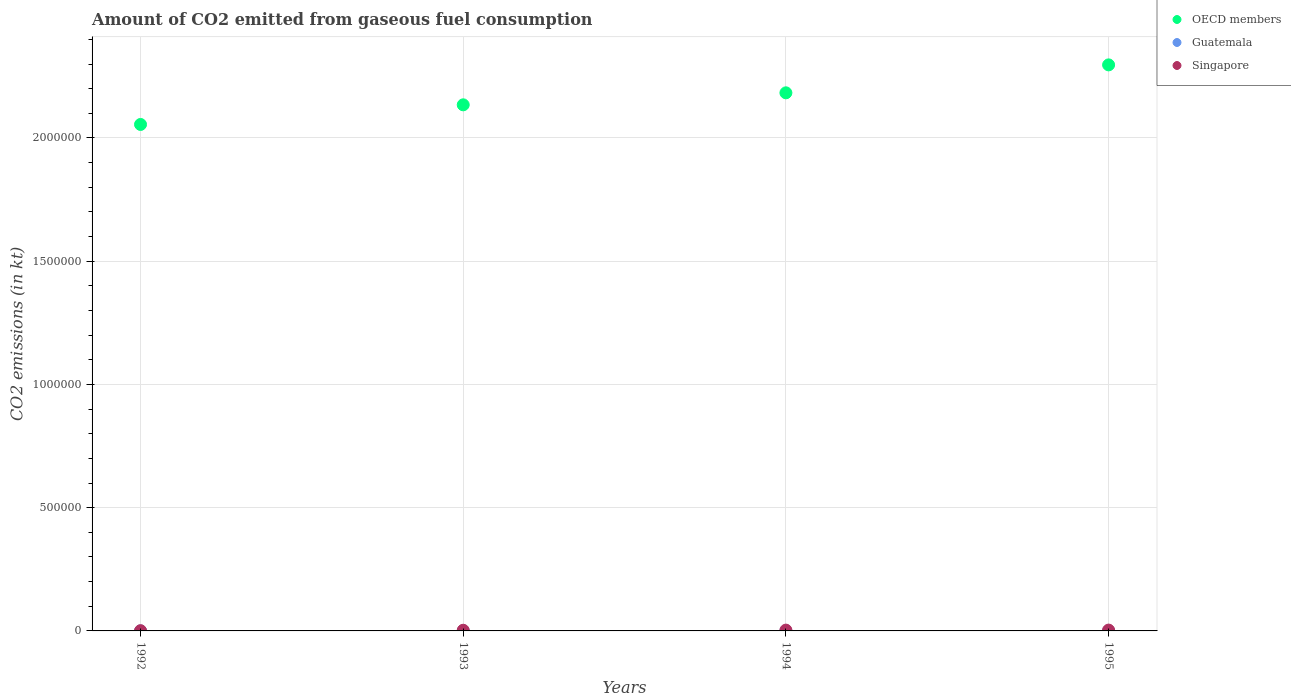How many different coloured dotlines are there?
Provide a succinct answer. 3. What is the amount of CO2 emitted in Guatemala in 1994?
Your answer should be very brief. 18.34. Across all years, what is the maximum amount of CO2 emitted in OECD members?
Give a very brief answer. 2.30e+06. Across all years, what is the minimum amount of CO2 emitted in Singapore?
Ensure brevity in your answer.  916.75. What is the total amount of CO2 emitted in OECD members in the graph?
Provide a succinct answer. 8.67e+06. What is the difference between the amount of CO2 emitted in OECD members in 1992 and that in 1994?
Provide a short and direct response. -1.28e+05. What is the difference between the amount of CO2 emitted in Guatemala in 1993 and the amount of CO2 emitted in OECD members in 1994?
Provide a succinct answer. -2.18e+06. What is the average amount of CO2 emitted in Singapore per year?
Ensure brevity in your answer.  2570.57. In the year 1994, what is the difference between the amount of CO2 emitted in Singapore and amount of CO2 emitted in OECD members?
Give a very brief answer. -2.18e+06. What is the ratio of the amount of CO2 emitted in Guatemala in 1994 to that in 1995?
Offer a terse response. 0.83. What is the difference between the highest and the second highest amount of CO2 emitted in Guatemala?
Your answer should be compact. 3.67. What is the difference between the highest and the lowest amount of CO2 emitted in Guatemala?
Offer a very short reply. 3.67. Is the sum of the amount of CO2 emitted in OECD members in 1992 and 1993 greater than the maximum amount of CO2 emitted in Guatemala across all years?
Keep it short and to the point. Yes. Is the amount of CO2 emitted in OECD members strictly greater than the amount of CO2 emitted in Singapore over the years?
Your response must be concise. Yes. How many dotlines are there?
Provide a short and direct response. 3. How many years are there in the graph?
Your answer should be compact. 4. Are the values on the major ticks of Y-axis written in scientific E-notation?
Provide a succinct answer. No. Does the graph contain grids?
Provide a short and direct response. Yes. How many legend labels are there?
Make the answer very short. 3. What is the title of the graph?
Ensure brevity in your answer.  Amount of CO2 emitted from gaseous fuel consumption. Does "Cayman Islands" appear as one of the legend labels in the graph?
Your answer should be compact. No. What is the label or title of the X-axis?
Make the answer very short. Years. What is the label or title of the Y-axis?
Offer a terse response. CO2 emissions (in kt). What is the CO2 emissions (in kt) in OECD members in 1992?
Ensure brevity in your answer.  2.05e+06. What is the CO2 emissions (in kt) of Guatemala in 1992?
Offer a terse response. 18.34. What is the CO2 emissions (in kt) of Singapore in 1992?
Offer a very short reply. 916.75. What is the CO2 emissions (in kt) in OECD members in 1993?
Keep it short and to the point. 2.13e+06. What is the CO2 emissions (in kt) in Guatemala in 1993?
Your answer should be compact. 18.34. What is the CO2 emissions (in kt) in Singapore in 1993?
Provide a short and direct response. 2728.25. What is the CO2 emissions (in kt) of OECD members in 1994?
Keep it short and to the point. 2.18e+06. What is the CO2 emissions (in kt) in Guatemala in 1994?
Your response must be concise. 18.34. What is the CO2 emissions (in kt) of Singapore in 1994?
Ensure brevity in your answer.  3252.63. What is the CO2 emissions (in kt) in OECD members in 1995?
Your response must be concise. 2.30e+06. What is the CO2 emissions (in kt) in Guatemala in 1995?
Offer a terse response. 22. What is the CO2 emissions (in kt) in Singapore in 1995?
Make the answer very short. 3384.64. Across all years, what is the maximum CO2 emissions (in kt) of OECD members?
Your answer should be very brief. 2.30e+06. Across all years, what is the maximum CO2 emissions (in kt) in Guatemala?
Offer a terse response. 22. Across all years, what is the maximum CO2 emissions (in kt) in Singapore?
Your answer should be very brief. 3384.64. Across all years, what is the minimum CO2 emissions (in kt) of OECD members?
Provide a short and direct response. 2.05e+06. Across all years, what is the minimum CO2 emissions (in kt) of Guatemala?
Provide a short and direct response. 18.34. Across all years, what is the minimum CO2 emissions (in kt) in Singapore?
Your answer should be very brief. 916.75. What is the total CO2 emissions (in kt) of OECD members in the graph?
Make the answer very short. 8.67e+06. What is the total CO2 emissions (in kt) in Guatemala in the graph?
Make the answer very short. 77.01. What is the total CO2 emissions (in kt) of Singapore in the graph?
Your answer should be very brief. 1.03e+04. What is the difference between the CO2 emissions (in kt) in OECD members in 1992 and that in 1993?
Your answer should be compact. -7.97e+04. What is the difference between the CO2 emissions (in kt) in Singapore in 1992 and that in 1993?
Offer a terse response. -1811.5. What is the difference between the CO2 emissions (in kt) in OECD members in 1992 and that in 1994?
Offer a terse response. -1.28e+05. What is the difference between the CO2 emissions (in kt) of Singapore in 1992 and that in 1994?
Keep it short and to the point. -2335.88. What is the difference between the CO2 emissions (in kt) in OECD members in 1992 and that in 1995?
Make the answer very short. -2.42e+05. What is the difference between the CO2 emissions (in kt) of Guatemala in 1992 and that in 1995?
Your response must be concise. -3.67. What is the difference between the CO2 emissions (in kt) in Singapore in 1992 and that in 1995?
Your response must be concise. -2467.89. What is the difference between the CO2 emissions (in kt) of OECD members in 1993 and that in 1994?
Provide a short and direct response. -4.87e+04. What is the difference between the CO2 emissions (in kt) of Guatemala in 1993 and that in 1994?
Your response must be concise. 0. What is the difference between the CO2 emissions (in kt) of Singapore in 1993 and that in 1994?
Your response must be concise. -524.38. What is the difference between the CO2 emissions (in kt) of OECD members in 1993 and that in 1995?
Ensure brevity in your answer.  -1.62e+05. What is the difference between the CO2 emissions (in kt) in Guatemala in 1993 and that in 1995?
Ensure brevity in your answer.  -3.67. What is the difference between the CO2 emissions (in kt) in Singapore in 1993 and that in 1995?
Your answer should be very brief. -656.39. What is the difference between the CO2 emissions (in kt) in OECD members in 1994 and that in 1995?
Ensure brevity in your answer.  -1.13e+05. What is the difference between the CO2 emissions (in kt) in Guatemala in 1994 and that in 1995?
Provide a short and direct response. -3.67. What is the difference between the CO2 emissions (in kt) of Singapore in 1994 and that in 1995?
Provide a succinct answer. -132.01. What is the difference between the CO2 emissions (in kt) of OECD members in 1992 and the CO2 emissions (in kt) of Guatemala in 1993?
Provide a short and direct response. 2.05e+06. What is the difference between the CO2 emissions (in kt) of OECD members in 1992 and the CO2 emissions (in kt) of Singapore in 1993?
Provide a short and direct response. 2.05e+06. What is the difference between the CO2 emissions (in kt) in Guatemala in 1992 and the CO2 emissions (in kt) in Singapore in 1993?
Your answer should be compact. -2709.91. What is the difference between the CO2 emissions (in kt) of OECD members in 1992 and the CO2 emissions (in kt) of Guatemala in 1994?
Your answer should be very brief. 2.05e+06. What is the difference between the CO2 emissions (in kt) of OECD members in 1992 and the CO2 emissions (in kt) of Singapore in 1994?
Offer a very short reply. 2.05e+06. What is the difference between the CO2 emissions (in kt) in Guatemala in 1992 and the CO2 emissions (in kt) in Singapore in 1994?
Your answer should be compact. -3234.29. What is the difference between the CO2 emissions (in kt) of OECD members in 1992 and the CO2 emissions (in kt) of Guatemala in 1995?
Your answer should be compact. 2.05e+06. What is the difference between the CO2 emissions (in kt) of OECD members in 1992 and the CO2 emissions (in kt) of Singapore in 1995?
Your answer should be very brief. 2.05e+06. What is the difference between the CO2 emissions (in kt) in Guatemala in 1992 and the CO2 emissions (in kt) in Singapore in 1995?
Offer a terse response. -3366.31. What is the difference between the CO2 emissions (in kt) in OECD members in 1993 and the CO2 emissions (in kt) in Guatemala in 1994?
Your answer should be compact. 2.13e+06. What is the difference between the CO2 emissions (in kt) of OECD members in 1993 and the CO2 emissions (in kt) of Singapore in 1994?
Provide a short and direct response. 2.13e+06. What is the difference between the CO2 emissions (in kt) in Guatemala in 1993 and the CO2 emissions (in kt) in Singapore in 1994?
Your response must be concise. -3234.29. What is the difference between the CO2 emissions (in kt) of OECD members in 1993 and the CO2 emissions (in kt) of Guatemala in 1995?
Provide a succinct answer. 2.13e+06. What is the difference between the CO2 emissions (in kt) of OECD members in 1993 and the CO2 emissions (in kt) of Singapore in 1995?
Your response must be concise. 2.13e+06. What is the difference between the CO2 emissions (in kt) of Guatemala in 1993 and the CO2 emissions (in kt) of Singapore in 1995?
Your response must be concise. -3366.31. What is the difference between the CO2 emissions (in kt) in OECD members in 1994 and the CO2 emissions (in kt) in Guatemala in 1995?
Offer a terse response. 2.18e+06. What is the difference between the CO2 emissions (in kt) of OECD members in 1994 and the CO2 emissions (in kt) of Singapore in 1995?
Your answer should be compact. 2.18e+06. What is the difference between the CO2 emissions (in kt) of Guatemala in 1994 and the CO2 emissions (in kt) of Singapore in 1995?
Your response must be concise. -3366.31. What is the average CO2 emissions (in kt) in OECD members per year?
Your answer should be compact. 2.17e+06. What is the average CO2 emissions (in kt) of Guatemala per year?
Your answer should be compact. 19.25. What is the average CO2 emissions (in kt) of Singapore per year?
Give a very brief answer. 2570.57. In the year 1992, what is the difference between the CO2 emissions (in kt) of OECD members and CO2 emissions (in kt) of Guatemala?
Provide a succinct answer. 2.05e+06. In the year 1992, what is the difference between the CO2 emissions (in kt) of OECD members and CO2 emissions (in kt) of Singapore?
Offer a terse response. 2.05e+06. In the year 1992, what is the difference between the CO2 emissions (in kt) of Guatemala and CO2 emissions (in kt) of Singapore?
Offer a very short reply. -898.41. In the year 1993, what is the difference between the CO2 emissions (in kt) of OECD members and CO2 emissions (in kt) of Guatemala?
Provide a short and direct response. 2.13e+06. In the year 1993, what is the difference between the CO2 emissions (in kt) of OECD members and CO2 emissions (in kt) of Singapore?
Offer a very short reply. 2.13e+06. In the year 1993, what is the difference between the CO2 emissions (in kt) in Guatemala and CO2 emissions (in kt) in Singapore?
Your response must be concise. -2709.91. In the year 1994, what is the difference between the CO2 emissions (in kt) in OECD members and CO2 emissions (in kt) in Guatemala?
Provide a short and direct response. 2.18e+06. In the year 1994, what is the difference between the CO2 emissions (in kt) of OECD members and CO2 emissions (in kt) of Singapore?
Ensure brevity in your answer.  2.18e+06. In the year 1994, what is the difference between the CO2 emissions (in kt) in Guatemala and CO2 emissions (in kt) in Singapore?
Provide a short and direct response. -3234.29. In the year 1995, what is the difference between the CO2 emissions (in kt) in OECD members and CO2 emissions (in kt) in Guatemala?
Make the answer very short. 2.30e+06. In the year 1995, what is the difference between the CO2 emissions (in kt) in OECD members and CO2 emissions (in kt) in Singapore?
Provide a short and direct response. 2.29e+06. In the year 1995, what is the difference between the CO2 emissions (in kt) in Guatemala and CO2 emissions (in kt) in Singapore?
Provide a short and direct response. -3362.64. What is the ratio of the CO2 emissions (in kt) in OECD members in 1992 to that in 1993?
Your answer should be very brief. 0.96. What is the ratio of the CO2 emissions (in kt) of Singapore in 1992 to that in 1993?
Make the answer very short. 0.34. What is the ratio of the CO2 emissions (in kt) in Guatemala in 1992 to that in 1994?
Ensure brevity in your answer.  1. What is the ratio of the CO2 emissions (in kt) of Singapore in 1992 to that in 1994?
Ensure brevity in your answer.  0.28. What is the ratio of the CO2 emissions (in kt) in OECD members in 1992 to that in 1995?
Give a very brief answer. 0.89. What is the ratio of the CO2 emissions (in kt) of Singapore in 1992 to that in 1995?
Give a very brief answer. 0.27. What is the ratio of the CO2 emissions (in kt) in OECD members in 1993 to that in 1994?
Offer a very short reply. 0.98. What is the ratio of the CO2 emissions (in kt) in Singapore in 1993 to that in 1994?
Ensure brevity in your answer.  0.84. What is the ratio of the CO2 emissions (in kt) in OECD members in 1993 to that in 1995?
Offer a terse response. 0.93. What is the ratio of the CO2 emissions (in kt) in Singapore in 1993 to that in 1995?
Your answer should be compact. 0.81. What is the ratio of the CO2 emissions (in kt) in OECD members in 1994 to that in 1995?
Ensure brevity in your answer.  0.95. What is the ratio of the CO2 emissions (in kt) in Guatemala in 1994 to that in 1995?
Offer a terse response. 0.83. What is the difference between the highest and the second highest CO2 emissions (in kt) of OECD members?
Keep it short and to the point. 1.13e+05. What is the difference between the highest and the second highest CO2 emissions (in kt) of Guatemala?
Your answer should be compact. 3.67. What is the difference between the highest and the second highest CO2 emissions (in kt) of Singapore?
Keep it short and to the point. 132.01. What is the difference between the highest and the lowest CO2 emissions (in kt) of OECD members?
Give a very brief answer. 2.42e+05. What is the difference between the highest and the lowest CO2 emissions (in kt) in Guatemala?
Offer a terse response. 3.67. What is the difference between the highest and the lowest CO2 emissions (in kt) of Singapore?
Provide a succinct answer. 2467.89. 